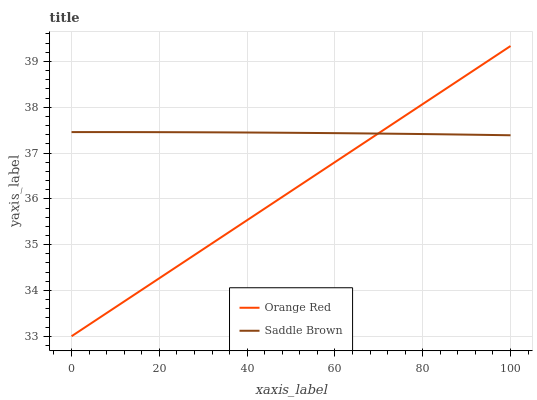Does Orange Red have the minimum area under the curve?
Answer yes or no. Yes. Does Saddle Brown have the maximum area under the curve?
Answer yes or no. Yes. Does Saddle Brown have the minimum area under the curve?
Answer yes or no. No. Is Orange Red the smoothest?
Answer yes or no. Yes. Is Saddle Brown the roughest?
Answer yes or no. Yes. Is Saddle Brown the smoothest?
Answer yes or no. No. Does Orange Red have the lowest value?
Answer yes or no. Yes. Does Saddle Brown have the lowest value?
Answer yes or no. No. Does Orange Red have the highest value?
Answer yes or no. Yes. Does Saddle Brown have the highest value?
Answer yes or no. No. Does Orange Red intersect Saddle Brown?
Answer yes or no. Yes. Is Orange Red less than Saddle Brown?
Answer yes or no. No. Is Orange Red greater than Saddle Brown?
Answer yes or no. No. 